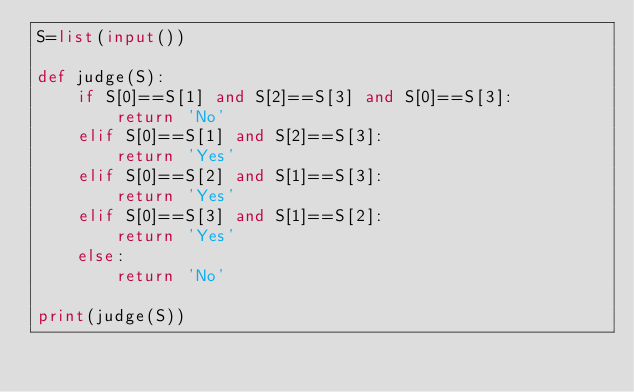<code> <loc_0><loc_0><loc_500><loc_500><_Python_>S=list(input())

def judge(S):
    if S[0]==S[1] and S[2]==S[3] and S[0]==S[3]:
        return 'No'        
    elif S[0]==S[1] and S[2]==S[3]:
        return 'Yes'
    elif S[0]==S[2] and S[1]==S[3]:
        return 'Yes'
    elif S[0]==S[3] and S[1]==S[2]:
        return 'Yes'
    else:
        return 'No'

print(judge(S))</code> 